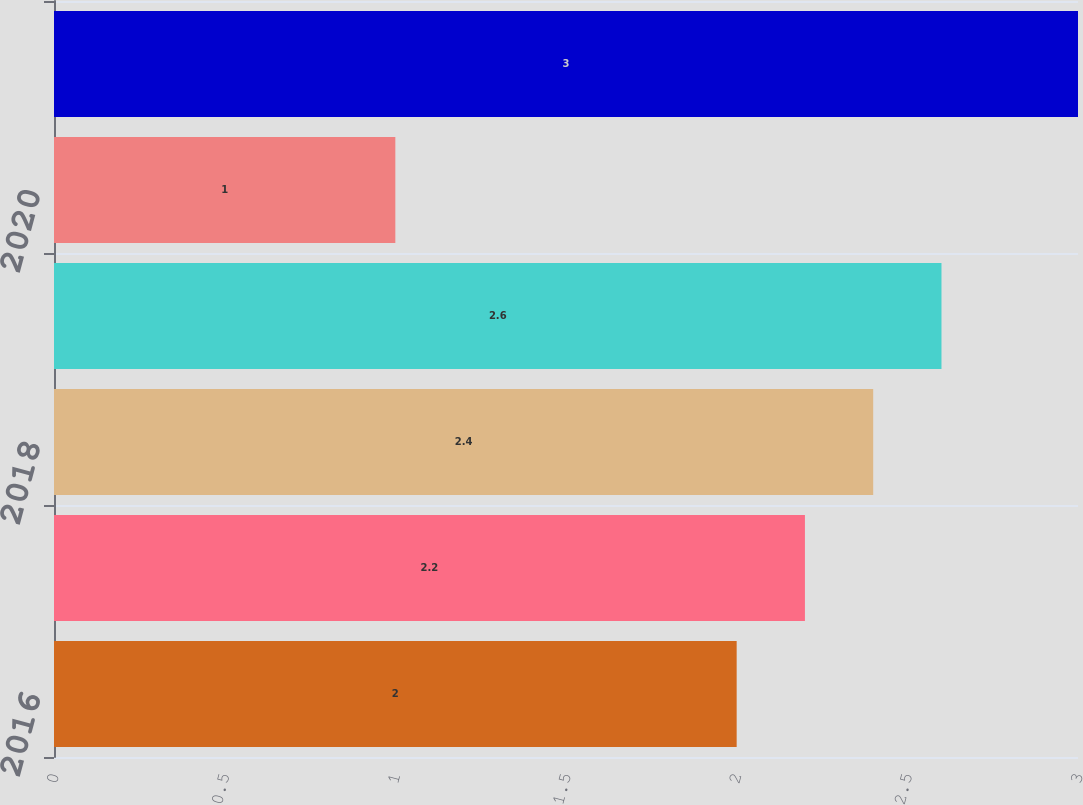<chart> <loc_0><loc_0><loc_500><loc_500><bar_chart><fcel>2016<fcel>2017<fcel>2018<fcel>2019<fcel>2020<fcel>Thereafter<nl><fcel>2<fcel>2.2<fcel>2.4<fcel>2.6<fcel>1<fcel>3<nl></chart> 